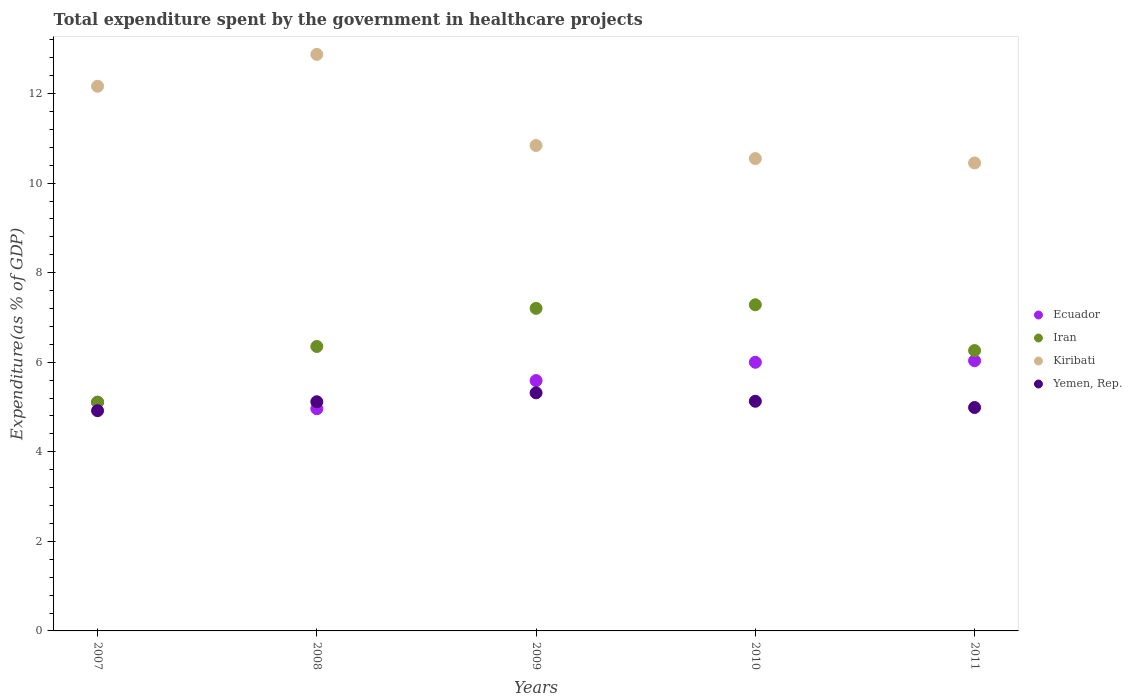What is the total expenditure spent by the government in healthcare projects in Kiribati in 2011?
Provide a succinct answer. 10.45. Across all years, what is the maximum total expenditure spent by the government in healthcare projects in Iran?
Provide a short and direct response. 7.28. Across all years, what is the minimum total expenditure spent by the government in healthcare projects in Ecuador?
Provide a short and direct response. 4.96. In which year was the total expenditure spent by the government in healthcare projects in Kiribati maximum?
Your answer should be compact. 2008. What is the total total expenditure spent by the government in healthcare projects in Iran in the graph?
Keep it short and to the point. 32.21. What is the difference between the total expenditure spent by the government in healthcare projects in Ecuador in 2008 and that in 2009?
Offer a very short reply. -0.63. What is the difference between the total expenditure spent by the government in healthcare projects in Kiribati in 2007 and the total expenditure spent by the government in healthcare projects in Iran in 2009?
Keep it short and to the point. 4.96. What is the average total expenditure spent by the government in healthcare projects in Yemen, Rep. per year?
Ensure brevity in your answer.  5.09. In the year 2009, what is the difference between the total expenditure spent by the government in healthcare projects in Iran and total expenditure spent by the government in healthcare projects in Yemen, Rep.?
Offer a terse response. 1.89. What is the ratio of the total expenditure spent by the government in healthcare projects in Ecuador in 2010 to that in 2011?
Give a very brief answer. 0.99. Is the total expenditure spent by the government in healthcare projects in Yemen, Rep. in 2009 less than that in 2011?
Provide a short and direct response. No. What is the difference between the highest and the second highest total expenditure spent by the government in healthcare projects in Iran?
Your response must be concise. 0.08. What is the difference between the highest and the lowest total expenditure spent by the government in healthcare projects in Kiribati?
Give a very brief answer. 2.42. In how many years, is the total expenditure spent by the government in healthcare projects in Yemen, Rep. greater than the average total expenditure spent by the government in healthcare projects in Yemen, Rep. taken over all years?
Provide a short and direct response. 3. Is the sum of the total expenditure spent by the government in healthcare projects in Iran in 2008 and 2011 greater than the maximum total expenditure spent by the government in healthcare projects in Ecuador across all years?
Provide a succinct answer. Yes. Does the total expenditure spent by the government in healthcare projects in Kiribati monotonically increase over the years?
Your answer should be compact. No. Is the total expenditure spent by the government in healthcare projects in Kiribati strictly greater than the total expenditure spent by the government in healthcare projects in Iran over the years?
Your answer should be very brief. Yes. Does the graph contain any zero values?
Your response must be concise. No. Does the graph contain grids?
Ensure brevity in your answer.  No. How many legend labels are there?
Ensure brevity in your answer.  4. What is the title of the graph?
Ensure brevity in your answer.  Total expenditure spent by the government in healthcare projects. Does "Netherlands" appear as one of the legend labels in the graph?
Make the answer very short. No. What is the label or title of the Y-axis?
Offer a terse response. Expenditure(as % of GDP). What is the Expenditure(as % of GDP) of Ecuador in 2007?
Offer a very short reply. 5.11. What is the Expenditure(as % of GDP) of Iran in 2007?
Offer a very short reply. 5.11. What is the Expenditure(as % of GDP) of Kiribati in 2007?
Make the answer very short. 12.16. What is the Expenditure(as % of GDP) of Yemen, Rep. in 2007?
Give a very brief answer. 4.92. What is the Expenditure(as % of GDP) of Ecuador in 2008?
Provide a succinct answer. 4.96. What is the Expenditure(as % of GDP) of Iran in 2008?
Ensure brevity in your answer.  6.35. What is the Expenditure(as % of GDP) in Kiribati in 2008?
Offer a very short reply. 12.87. What is the Expenditure(as % of GDP) of Yemen, Rep. in 2008?
Your answer should be compact. 5.12. What is the Expenditure(as % of GDP) of Ecuador in 2009?
Provide a short and direct response. 5.59. What is the Expenditure(as % of GDP) in Iran in 2009?
Keep it short and to the point. 7.2. What is the Expenditure(as % of GDP) in Kiribati in 2009?
Your response must be concise. 10.84. What is the Expenditure(as % of GDP) in Yemen, Rep. in 2009?
Offer a terse response. 5.32. What is the Expenditure(as % of GDP) in Ecuador in 2010?
Offer a very short reply. 6. What is the Expenditure(as % of GDP) in Iran in 2010?
Your response must be concise. 7.28. What is the Expenditure(as % of GDP) of Kiribati in 2010?
Make the answer very short. 10.55. What is the Expenditure(as % of GDP) in Yemen, Rep. in 2010?
Ensure brevity in your answer.  5.13. What is the Expenditure(as % of GDP) in Ecuador in 2011?
Your answer should be very brief. 6.03. What is the Expenditure(as % of GDP) of Iran in 2011?
Provide a short and direct response. 6.26. What is the Expenditure(as % of GDP) in Kiribati in 2011?
Keep it short and to the point. 10.45. What is the Expenditure(as % of GDP) of Yemen, Rep. in 2011?
Offer a terse response. 4.99. Across all years, what is the maximum Expenditure(as % of GDP) in Ecuador?
Your answer should be compact. 6.03. Across all years, what is the maximum Expenditure(as % of GDP) in Iran?
Ensure brevity in your answer.  7.28. Across all years, what is the maximum Expenditure(as % of GDP) in Kiribati?
Offer a terse response. 12.87. Across all years, what is the maximum Expenditure(as % of GDP) of Yemen, Rep.?
Your answer should be compact. 5.32. Across all years, what is the minimum Expenditure(as % of GDP) of Ecuador?
Offer a very short reply. 4.96. Across all years, what is the minimum Expenditure(as % of GDP) of Iran?
Your answer should be very brief. 5.11. Across all years, what is the minimum Expenditure(as % of GDP) in Kiribati?
Provide a succinct answer. 10.45. Across all years, what is the minimum Expenditure(as % of GDP) of Yemen, Rep.?
Your answer should be very brief. 4.92. What is the total Expenditure(as % of GDP) in Ecuador in the graph?
Offer a terse response. 27.69. What is the total Expenditure(as % of GDP) of Iran in the graph?
Ensure brevity in your answer.  32.21. What is the total Expenditure(as % of GDP) of Kiribati in the graph?
Your answer should be very brief. 56.88. What is the total Expenditure(as % of GDP) of Yemen, Rep. in the graph?
Your answer should be compact. 25.47. What is the difference between the Expenditure(as % of GDP) of Ecuador in 2007 and that in 2008?
Your response must be concise. 0.14. What is the difference between the Expenditure(as % of GDP) of Iran in 2007 and that in 2008?
Your answer should be compact. -1.24. What is the difference between the Expenditure(as % of GDP) in Kiribati in 2007 and that in 2008?
Give a very brief answer. -0.71. What is the difference between the Expenditure(as % of GDP) in Yemen, Rep. in 2007 and that in 2008?
Ensure brevity in your answer.  -0.2. What is the difference between the Expenditure(as % of GDP) in Ecuador in 2007 and that in 2009?
Your answer should be compact. -0.48. What is the difference between the Expenditure(as % of GDP) of Iran in 2007 and that in 2009?
Your answer should be compact. -2.09. What is the difference between the Expenditure(as % of GDP) of Kiribati in 2007 and that in 2009?
Keep it short and to the point. 1.32. What is the difference between the Expenditure(as % of GDP) of Yemen, Rep. in 2007 and that in 2009?
Give a very brief answer. -0.4. What is the difference between the Expenditure(as % of GDP) in Ecuador in 2007 and that in 2010?
Your answer should be compact. -0.89. What is the difference between the Expenditure(as % of GDP) in Iran in 2007 and that in 2010?
Keep it short and to the point. -2.17. What is the difference between the Expenditure(as % of GDP) of Kiribati in 2007 and that in 2010?
Make the answer very short. 1.61. What is the difference between the Expenditure(as % of GDP) in Yemen, Rep. in 2007 and that in 2010?
Give a very brief answer. -0.21. What is the difference between the Expenditure(as % of GDP) of Ecuador in 2007 and that in 2011?
Your response must be concise. -0.93. What is the difference between the Expenditure(as % of GDP) of Iran in 2007 and that in 2011?
Provide a short and direct response. -1.15. What is the difference between the Expenditure(as % of GDP) in Kiribati in 2007 and that in 2011?
Your answer should be very brief. 1.71. What is the difference between the Expenditure(as % of GDP) in Yemen, Rep. in 2007 and that in 2011?
Your answer should be very brief. -0.07. What is the difference between the Expenditure(as % of GDP) in Ecuador in 2008 and that in 2009?
Give a very brief answer. -0.63. What is the difference between the Expenditure(as % of GDP) of Iran in 2008 and that in 2009?
Your answer should be compact. -0.85. What is the difference between the Expenditure(as % of GDP) of Kiribati in 2008 and that in 2009?
Make the answer very short. 2.03. What is the difference between the Expenditure(as % of GDP) in Yemen, Rep. in 2008 and that in 2009?
Offer a very short reply. -0.2. What is the difference between the Expenditure(as % of GDP) of Ecuador in 2008 and that in 2010?
Your answer should be very brief. -1.04. What is the difference between the Expenditure(as % of GDP) in Iran in 2008 and that in 2010?
Ensure brevity in your answer.  -0.93. What is the difference between the Expenditure(as % of GDP) in Kiribati in 2008 and that in 2010?
Ensure brevity in your answer.  2.33. What is the difference between the Expenditure(as % of GDP) in Yemen, Rep. in 2008 and that in 2010?
Keep it short and to the point. -0.01. What is the difference between the Expenditure(as % of GDP) of Ecuador in 2008 and that in 2011?
Provide a short and direct response. -1.07. What is the difference between the Expenditure(as % of GDP) of Iran in 2008 and that in 2011?
Keep it short and to the point. 0.09. What is the difference between the Expenditure(as % of GDP) of Kiribati in 2008 and that in 2011?
Give a very brief answer. 2.42. What is the difference between the Expenditure(as % of GDP) in Yemen, Rep. in 2008 and that in 2011?
Provide a succinct answer. 0.13. What is the difference between the Expenditure(as % of GDP) in Ecuador in 2009 and that in 2010?
Your response must be concise. -0.41. What is the difference between the Expenditure(as % of GDP) in Iran in 2009 and that in 2010?
Provide a short and direct response. -0.08. What is the difference between the Expenditure(as % of GDP) of Kiribati in 2009 and that in 2010?
Your response must be concise. 0.29. What is the difference between the Expenditure(as % of GDP) of Yemen, Rep. in 2009 and that in 2010?
Your answer should be compact. 0.19. What is the difference between the Expenditure(as % of GDP) of Ecuador in 2009 and that in 2011?
Your answer should be compact. -0.44. What is the difference between the Expenditure(as % of GDP) in Iran in 2009 and that in 2011?
Your response must be concise. 0.94. What is the difference between the Expenditure(as % of GDP) of Kiribati in 2009 and that in 2011?
Offer a terse response. 0.39. What is the difference between the Expenditure(as % of GDP) of Yemen, Rep. in 2009 and that in 2011?
Offer a very short reply. 0.33. What is the difference between the Expenditure(as % of GDP) of Ecuador in 2010 and that in 2011?
Your response must be concise. -0.03. What is the difference between the Expenditure(as % of GDP) of Iran in 2010 and that in 2011?
Your answer should be compact. 1.02. What is the difference between the Expenditure(as % of GDP) of Kiribati in 2010 and that in 2011?
Provide a succinct answer. 0.1. What is the difference between the Expenditure(as % of GDP) in Yemen, Rep. in 2010 and that in 2011?
Your answer should be very brief. 0.14. What is the difference between the Expenditure(as % of GDP) in Ecuador in 2007 and the Expenditure(as % of GDP) in Iran in 2008?
Provide a short and direct response. -1.25. What is the difference between the Expenditure(as % of GDP) in Ecuador in 2007 and the Expenditure(as % of GDP) in Kiribati in 2008?
Provide a succinct answer. -7.77. What is the difference between the Expenditure(as % of GDP) of Ecuador in 2007 and the Expenditure(as % of GDP) of Yemen, Rep. in 2008?
Ensure brevity in your answer.  -0.01. What is the difference between the Expenditure(as % of GDP) of Iran in 2007 and the Expenditure(as % of GDP) of Kiribati in 2008?
Keep it short and to the point. -7.77. What is the difference between the Expenditure(as % of GDP) in Iran in 2007 and the Expenditure(as % of GDP) in Yemen, Rep. in 2008?
Offer a very short reply. -0.01. What is the difference between the Expenditure(as % of GDP) in Kiribati in 2007 and the Expenditure(as % of GDP) in Yemen, Rep. in 2008?
Offer a very short reply. 7.05. What is the difference between the Expenditure(as % of GDP) in Ecuador in 2007 and the Expenditure(as % of GDP) in Iran in 2009?
Offer a terse response. -2.1. What is the difference between the Expenditure(as % of GDP) in Ecuador in 2007 and the Expenditure(as % of GDP) in Kiribati in 2009?
Provide a short and direct response. -5.73. What is the difference between the Expenditure(as % of GDP) of Ecuador in 2007 and the Expenditure(as % of GDP) of Yemen, Rep. in 2009?
Ensure brevity in your answer.  -0.21. What is the difference between the Expenditure(as % of GDP) of Iran in 2007 and the Expenditure(as % of GDP) of Kiribati in 2009?
Your answer should be compact. -5.73. What is the difference between the Expenditure(as % of GDP) in Iran in 2007 and the Expenditure(as % of GDP) in Yemen, Rep. in 2009?
Make the answer very short. -0.21. What is the difference between the Expenditure(as % of GDP) of Kiribati in 2007 and the Expenditure(as % of GDP) of Yemen, Rep. in 2009?
Keep it short and to the point. 6.85. What is the difference between the Expenditure(as % of GDP) in Ecuador in 2007 and the Expenditure(as % of GDP) in Iran in 2010?
Offer a very short reply. -2.18. What is the difference between the Expenditure(as % of GDP) of Ecuador in 2007 and the Expenditure(as % of GDP) of Kiribati in 2010?
Offer a very short reply. -5.44. What is the difference between the Expenditure(as % of GDP) of Ecuador in 2007 and the Expenditure(as % of GDP) of Yemen, Rep. in 2010?
Your answer should be compact. -0.02. What is the difference between the Expenditure(as % of GDP) in Iran in 2007 and the Expenditure(as % of GDP) in Kiribati in 2010?
Keep it short and to the point. -5.44. What is the difference between the Expenditure(as % of GDP) of Iran in 2007 and the Expenditure(as % of GDP) of Yemen, Rep. in 2010?
Offer a terse response. -0.02. What is the difference between the Expenditure(as % of GDP) in Kiribati in 2007 and the Expenditure(as % of GDP) in Yemen, Rep. in 2010?
Your answer should be very brief. 7.03. What is the difference between the Expenditure(as % of GDP) in Ecuador in 2007 and the Expenditure(as % of GDP) in Iran in 2011?
Provide a succinct answer. -1.16. What is the difference between the Expenditure(as % of GDP) in Ecuador in 2007 and the Expenditure(as % of GDP) in Kiribati in 2011?
Provide a short and direct response. -5.34. What is the difference between the Expenditure(as % of GDP) of Ecuador in 2007 and the Expenditure(as % of GDP) of Yemen, Rep. in 2011?
Ensure brevity in your answer.  0.12. What is the difference between the Expenditure(as % of GDP) of Iran in 2007 and the Expenditure(as % of GDP) of Kiribati in 2011?
Keep it short and to the point. -5.34. What is the difference between the Expenditure(as % of GDP) of Iran in 2007 and the Expenditure(as % of GDP) of Yemen, Rep. in 2011?
Give a very brief answer. 0.12. What is the difference between the Expenditure(as % of GDP) of Kiribati in 2007 and the Expenditure(as % of GDP) of Yemen, Rep. in 2011?
Your answer should be very brief. 7.17. What is the difference between the Expenditure(as % of GDP) in Ecuador in 2008 and the Expenditure(as % of GDP) in Iran in 2009?
Ensure brevity in your answer.  -2.24. What is the difference between the Expenditure(as % of GDP) in Ecuador in 2008 and the Expenditure(as % of GDP) in Kiribati in 2009?
Your response must be concise. -5.88. What is the difference between the Expenditure(as % of GDP) of Ecuador in 2008 and the Expenditure(as % of GDP) of Yemen, Rep. in 2009?
Provide a succinct answer. -0.35. What is the difference between the Expenditure(as % of GDP) in Iran in 2008 and the Expenditure(as % of GDP) in Kiribati in 2009?
Ensure brevity in your answer.  -4.49. What is the difference between the Expenditure(as % of GDP) of Iran in 2008 and the Expenditure(as % of GDP) of Yemen, Rep. in 2009?
Offer a terse response. 1.04. What is the difference between the Expenditure(as % of GDP) of Kiribati in 2008 and the Expenditure(as % of GDP) of Yemen, Rep. in 2009?
Your answer should be compact. 7.56. What is the difference between the Expenditure(as % of GDP) in Ecuador in 2008 and the Expenditure(as % of GDP) in Iran in 2010?
Provide a succinct answer. -2.32. What is the difference between the Expenditure(as % of GDP) of Ecuador in 2008 and the Expenditure(as % of GDP) of Kiribati in 2010?
Your answer should be compact. -5.59. What is the difference between the Expenditure(as % of GDP) in Ecuador in 2008 and the Expenditure(as % of GDP) in Yemen, Rep. in 2010?
Your answer should be compact. -0.17. What is the difference between the Expenditure(as % of GDP) in Iran in 2008 and the Expenditure(as % of GDP) in Kiribati in 2010?
Give a very brief answer. -4.2. What is the difference between the Expenditure(as % of GDP) of Iran in 2008 and the Expenditure(as % of GDP) of Yemen, Rep. in 2010?
Make the answer very short. 1.22. What is the difference between the Expenditure(as % of GDP) of Kiribati in 2008 and the Expenditure(as % of GDP) of Yemen, Rep. in 2010?
Offer a terse response. 7.75. What is the difference between the Expenditure(as % of GDP) of Ecuador in 2008 and the Expenditure(as % of GDP) of Iran in 2011?
Your answer should be very brief. -1.3. What is the difference between the Expenditure(as % of GDP) of Ecuador in 2008 and the Expenditure(as % of GDP) of Kiribati in 2011?
Offer a terse response. -5.49. What is the difference between the Expenditure(as % of GDP) in Ecuador in 2008 and the Expenditure(as % of GDP) in Yemen, Rep. in 2011?
Offer a terse response. -0.03. What is the difference between the Expenditure(as % of GDP) in Iran in 2008 and the Expenditure(as % of GDP) in Kiribati in 2011?
Your response must be concise. -4.1. What is the difference between the Expenditure(as % of GDP) of Iran in 2008 and the Expenditure(as % of GDP) of Yemen, Rep. in 2011?
Offer a very short reply. 1.36. What is the difference between the Expenditure(as % of GDP) in Kiribati in 2008 and the Expenditure(as % of GDP) in Yemen, Rep. in 2011?
Your answer should be very brief. 7.89. What is the difference between the Expenditure(as % of GDP) of Ecuador in 2009 and the Expenditure(as % of GDP) of Iran in 2010?
Provide a short and direct response. -1.69. What is the difference between the Expenditure(as % of GDP) of Ecuador in 2009 and the Expenditure(as % of GDP) of Kiribati in 2010?
Provide a short and direct response. -4.96. What is the difference between the Expenditure(as % of GDP) of Ecuador in 2009 and the Expenditure(as % of GDP) of Yemen, Rep. in 2010?
Keep it short and to the point. 0.46. What is the difference between the Expenditure(as % of GDP) in Iran in 2009 and the Expenditure(as % of GDP) in Kiribati in 2010?
Your response must be concise. -3.35. What is the difference between the Expenditure(as % of GDP) of Iran in 2009 and the Expenditure(as % of GDP) of Yemen, Rep. in 2010?
Your answer should be compact. 2.07. What is the difference between the Expenditure(as % of GDP) of Kiribati in 2009 and the Expenditure(as % of GDP) of Yemen, Rep. in 2010?
Your response must be concise. 5.71. What is the difference between the Expenditure(as % of GDP) in Ecuador in 2009 and the Expenditure(as % of GDP) in Iran in 2011?
Provide a succinct answer. -0.67. What is the difference between the Expenditure(as % of GDP) in Ecuador in 2009 and the Expenditure(as % of GDP) in Kiribati in 2011?
Give a very brief answer. -4.86. What is the difference between the Expenditure(as % of GDP) of Ecuador in 2009 and the Expenditure(as % of GDP) of Yemen, Rep. in 2011?
Offer a very short reply. 0.6. What is the difference between the Expenditure(as % of GDP) in Iran in 2009 and the Expenditure(as % of GDP) in Kiribati in 2011?
Offer a terse response. -3.25. What is the difference between the Expenditure(as % of GDP) in Iran in 2009 and the Expenditure(as % of GDP) in Yemen, Rep. in 2011?
Provide a short and direct response. 2.21. What is the difference between the Expenditure(as % of GDP) in Kiribati in 2009 and the Expenditure(as % of GDP) in Yemen, Rep. in 2011?
Your answer should be very brief. 5.85. What is the difference between the Expenditure(as % of GDP) in Ecuador in 2010 and the Expenditure(as % of GDP) in Iran in 2011?
Your answer should be very brief. -0.26. What is the difference between the Expenditure(as % of GDP) of Ecuador in 2010 and the Expenditure(as % of GDP) of Kiribati in 2011?
Keep it short and to the point. -4.45. What is the difference between the Expenditure(as % of GDP) in Ecuador in 2010 and the Expenditure(as % of GDP) in Yemen, Rep. in 2011?
Keep it short and to the point. 1.01. What is the difference between the Expenditure(as % of GDP) in Iran in 2010 and the Expenditure(as % of GDP) in Kiribati in 2011?
Give a very brief answer. -3.17. What is the difference between the Expenditure(as % of GDP) in Iran in 2010 and the Expenditure(as % of GDP) in Yemen, Rep. in 2011?
Offer a very short reply. 2.29. What is the difference between the Expenditure(as % of GDP) of Kiribati in 2010 and the Expenditure(as % of GDP) of Yemen, Rep. in 2011?
Make the answer very short. 5.56. What is the average Expenditure(as % of GDP) in Ecuador per year?
Give a very brief answer. 5.54. What is the average Expenditure(as % of GDP) in Iran per year?
Offer a terse response. 6.44. What is the average Expenditure(as % of GDP) in Kiribati per year?
Offer a terse response. 11.38. What is the average Expenditure(as % of GDP) in Yemen, Rep. per year?
Your response must be concise. 5.09. In the year 2007, what is the difference between the Expenditure(as % of GDP) of Ecuador and Expenditure(as % of GDP) of Iran?
Ensure brevity in your answer.  -0. In the year 2007, what is the difference between the Expenditure(as % of GDP) in Ecuador and Expenditure(as % of GDP) in Kiribati?
Provide a succinct answer. -7.06. In the year 2007, what is the difference between the Expenditure(as % of GDP) in Ecuador and Expenditure(as % of GDP) in Yemen, Rep.?
Your answer should be very brief. 0.19. In the year 2007, what is the difference between the Expenditure(as % of GDP) of Iran and Expenditure(as % of GDP) of Kiribati?
Offer a terse response. -7.05. In the year 2007, what is the difference between the Expenditure(as % of GDP) of Iran and Expenditure(as % of GDP) of Yemen, Rep.?
Give a very brief answer. 0.19. In the year 2007, what is the difference between the Expenditure(as % of GDP) in Kiribati and Expenditure(as % of GDP) in Yemen, Rep.?
Provide a short and direct response. 7.24. In the year 2008, what is the difference between the Expenditure(as % of GDP) in Ecuador and Expenditure(as % of GDP) in Iran?
Offer a very short reply. -1.39. In the year 2008, what is the difference between the Expenditure(as % of GDP) of Ecuador and Expenditure(as % of GDP) of Kiribati?
Make the answer very short. -7.91. In the year 2008, what is the difference between the Expenditure(as % of GDP) of Ecuador and Expenditure(as % of GDP) of Yemen, Rep.?
Offer a terse response. -0.16. In the year 2008, what is the difference between the Expenditure(as % of GDP) of Iran and Expenditure(as % of GDP) of Kiribati?
Your response must be concise. -6.52. In the year 2008, what is the difference between the Expenditure(as % of GDP) in Iran and Expenditure(as % of GDP) in Yemen, Rep.?
Your answer should be compact. 1.23. In the year 2008, what is the difference between the Expenditure(as % of GDP) in Kiribati and Expenditure(as % of GDP) in Yemen, Rep.?
Provide a short and direct response. 7.76. In the year 2009, what is the difference between the Expenditure(as % of GDP) in Ecuador and Expenditure(as % of GDP) in Iran?
Provide a short and direct response. -1.61. In the year 2009, what is the difference between the Expenditure(as % of GDP) in Ecuador and Expenditure(as % of GDP) in Kiribati?
Ensure brevity in your answer.  -5.25. In the year 2009, what is the difference between the Expenditure(as % of GDP) of Ecuador and Expenditure(as % of GDP) of Yemen, Rep.?
Your response must be concise. 0.27. In the year 2009, what is the difference between the Expenditure(as % of GDP) of Iran and Expenditure(as % of GDP) of Kiribati?
Make the answer very short. -3.64. In the year 2009, what is the difference between the Expenditure(as % of GDP) in Iran and Expenditure(as % of GDP) in Yemen, Rep.?
Your answer should be compact. 1.89. In the year 2009, what is the difference between the Expenditure(as % of GDP) of Kiribati and Expenditure(as % of GDP) of Yemen, Rep.?
Your response must be concise. 5.52. In the year 2010, what is the difference between the Expenditure(as % of GDP) in Ecuador and Expenditure(as % of GDP) in Iran?
Offer a terse response. -1.28. In the year 2010, what is the difference between the Expenditure(as % of GDP) in Ecuador and Expenditure(as % of GDP) in Kiribati?
Give a very brief answer. -4.55. In the year 2010, what is the difference between the Expenditure(as % of GDP) of Ecuador and Expenditure(as % of GDP) of Yemen, Rep.?
Offer a very short reply. 0.87. In the year 2010, what is the difference between the Expenditure(as % of GDP) of Iran and Expenditure(as % of GDP) of Kiribati?
Your answer should be compact. -3.27. In the year 2010, what is the difference between the Expenditure(as % of GDP) of Iran and Expenditure(as % of GDP) of Yemen, Rep.?
Your response must be concise. 2.15. In the year 2010, what is the difference between the Expenditure(as % of GDP) of Kiribati and Expenditure(as % of GDP) of Yemen, Rep.?
Give a very brief answer. 5.42. In the year 2011, what is the difference between the Expenditure(as % of GDP) in Ecuador and Expenditure(as % of GDP) in Iran?
Provide a short and direct response. -0.23. In the year 2011, what is the difference between the Expenditure(as % of GDP) in Ecuador and Expenditure(as % of GDP) in Kiribati?
Your answer should be very brief. -4.42. In the year 2011, what is the difference between the Expenditure(as % of GDP) in Ecuador and Expenditure(as % of GDP) in Yemen, Rep.?
Make the answer very short. 1.04. In the year 2011, what is the difference between the Expenditure(as % of GDP) of Iran and Expenditure(as % of GDP) of Kiribati?
Provide a succinct answer. -4.19. In the year 2011, what is the difference between the Expenditure(as % of GDP) in Iran and Expenditure(as % of GDP) in Yemen, Rep.?
Give a very brief answer. 1.27. In the year 2011, what is the difference between the Expenditure(as % of GDP) of Kiribati and Expenditure(as % of GDP) of Yemen, Rep.?
Offer a terse response. 5.46. What is the ratio of the Expenditure(as % of GDP) in Ecuador in 2007 to that in 2008?
Your answer should be very brief. 1.03. What is the ratio of the Expenditure(as % of GDP) of Iran in 2007 to that in 2008?
Your response must be concise. 0.8. What is the ratio of the Expenditure(as % of GDP) of Kiribati in 2007 to that in 2008?
Keep it short and to the point. 0.94. What is the ratio of the Expenditure(as % of GDP) of Yemen, Rep. in 2007 to that in 2008?
Keep it short and to the point. 0.96. What is the ratio of the Expenditure(as % of GDP) of Ecuador in 2007 to that in 2009?
Make the answer very short. 0.91. What is the ratio of the Expenditure(as % of GDP) of Iran in 2007 to that in 2009?
Make the answer very short. 0.71. What is the ratio of the Expenditure(as % of GDP) of Kiribati in 2007 to that in 2009?
Provide a succinct answer. 1.12. What is the ratio of the Expenditure(as % of GDP) in Yemen, Rep. in 2007 to that in 2009?
Offer a very short reply. 0.93. What is the ratio of the Expenditure(as % of GDP) in Ecuador in 2007 to that in 2010?
Offer a terse response. 0.85. What is the ratio of the Expenditure(as % of GDP) of Iran in 2007 to that in 2010?
Make the answer very short. 0.7. What is the ratio of the Expenditure(as % of GDP) of Kiribati in 2007 to that in 2010?
Keep it short and to the point. 1.15. What is the ratio of the Expenditure(as % of GDP) in Yemen, Rep. in 2007 to that in 2010?
Make the answer very short. 0.96. What is the ratio of the Expenditure(as % of GDP) of Ecuador in 2007 to that in 2011?
Offer a terse response. 0.85. What is the ratio of the Expenditure(as % of GDP) in Iran in 2007 to that in 2011?
Keep it short and to the point. 0.82. What is the ratio of the Expenditure(as % of GDP) in Kiribati in 2007 to that in 2011?
Your answer should be compact. 1.16. What is the ratio of the Expenditure(as % of GDP) in Yemen, Rep. in 2007 to that in 2011?
Give a very brief answer. 0.99. What is the ratio of the Expenditure(as % of GDP) in Ecuador in 2008 to that in 2009?
Your response must be concise. 0.89. What is the ratio of the Expenditure(as % of GDP) in Iran in 2008 to that in 2009?
Your answer should be very brief. 0.88. What is the ratio of the Expenditure(as % of GDP) of Kiribati in 2008 to that in 2009?
Keep it short and to the point. 1.19. What is the ratio of the Expenditure(as % of GDP) in Yemen, Rep. in 2008 to that in 2009?
Your answer should be very brief. 0.96. What is the ratio of the Expenditure(as % of GDP) of Ecuador in 2008 to that in 2010?
Keep it short and to the point. 0.83. What is the ratio of the Expenditure(as % of GDP) in Iran in 2008 to that in 2010?
Offer a terse response. 0.87. What is the ratio of the Expenditure(as % of GDP) in Kiribati in 2008 to that in 2010?
Offer a terse response. 1.22. What is the ratio of the Expenditure(as % of GDP) of Yemen, Rep. in 2008 to that in 2010?
Offer a very short reply. 1. What is the ratio of the Expenditure(as % of GDP) of Ecuador in 2008 to that in 2011?
Your answer should be compact. 0.82. What is the ratio of the Expenditure(as % of GDP) in Iran in 2008 to that in 2011?
Offer a very short reply. 1.01. What is the ratio of the Expenditure(as % of GDP) in Kiribati in 2008 to that in 2011?
Offer a very short reply. 1.23. What is the ratio of the Expenditure(as % of GDP) in Yemen, Rep. in 2008 to that in 2011?
Give a very brief answer. 1.03. What is the ratio of the Expenditure(as % of GDP) in Ecuador in 2009 to that in 2010?
Make the answer very short. 0.93. What is the ratio of the Expenditure(as % of GDP) in Kiribati in 2009 to that in 2010?
Offer a very short reply. 1.03. What is the ratio of the Expenditure(as % of GDP) in Yemen, Rep. in 2009 to that in 2010?
Your answer should be compact. 1.04. What is the ratio of the Expenditure(as % of GDP) of Ecuador in 2009 to that in 2011?
Ensure brevity in your answer.  0.93. What is the ratio of the Expenditure(as % of GDP) of Iran in 2009 to that in 2011?
Your answer should be very brief. 1.15. What is the ratio of the Expenditure(as % of GDP) in Kiribati in 2009 to that in 2011?
Your response must be concise. 1.04. What is the ratio of the Expenditure(as % of GDP) of Yemen, Rep. in 2009 to that in 2011?
Give a very brief answer. 1.07. What is the ratio of the Expenditure(as % of GDP) of Iran in 2010 to that in 2011?
Provide a short and direct response. 1.16. What is the ratio of the Expenditure(as % of GDP) in Kiribati in 2010 to that in 2011?
Your answer should be compact. 1.01. What is the ratio of the Expenditure(as % of GDP) of Yemen, Rep. in 2010 to that in 2011?
Ensure brevity in your answer.  1.03. What is the difference between the highest and the second highest Expenditure(as % of GDP) of Ecuador?
Ensure brevity in your answer.  0.03. What is the difference between the highest and the second highest Expenditure(as % of GDP) of Iran?
Offer a very short reply. 0.08. What is the difference between the highest and the second highest Expenditure(as % of GDP) in Kiribati?
Give a very brief answer. 0.71. What is the difference between the highest and the second highest Expenditure(as % of GDP) in Yemen, Rep.?
Provide a succinct answer. 0.19. What is the difference between the highest and the lowest Expenditure(as % of GDP) in Ecuador?
Give a very brief answer. 1.07. What is the difference between the highest and the lowest Expenditure(as % of GDP) of Iran?
Give a very brief answer. 2.17. What is the difference between the highest and the lowest Expenditure(as % of GDP) in Kiribati?
Offer a very short reply. 2.42. What is the difference between the highest and the lowest Expenditure(as % of GDP) of Yemen, Rep.?
Provide a short and direct response. 0.4. 